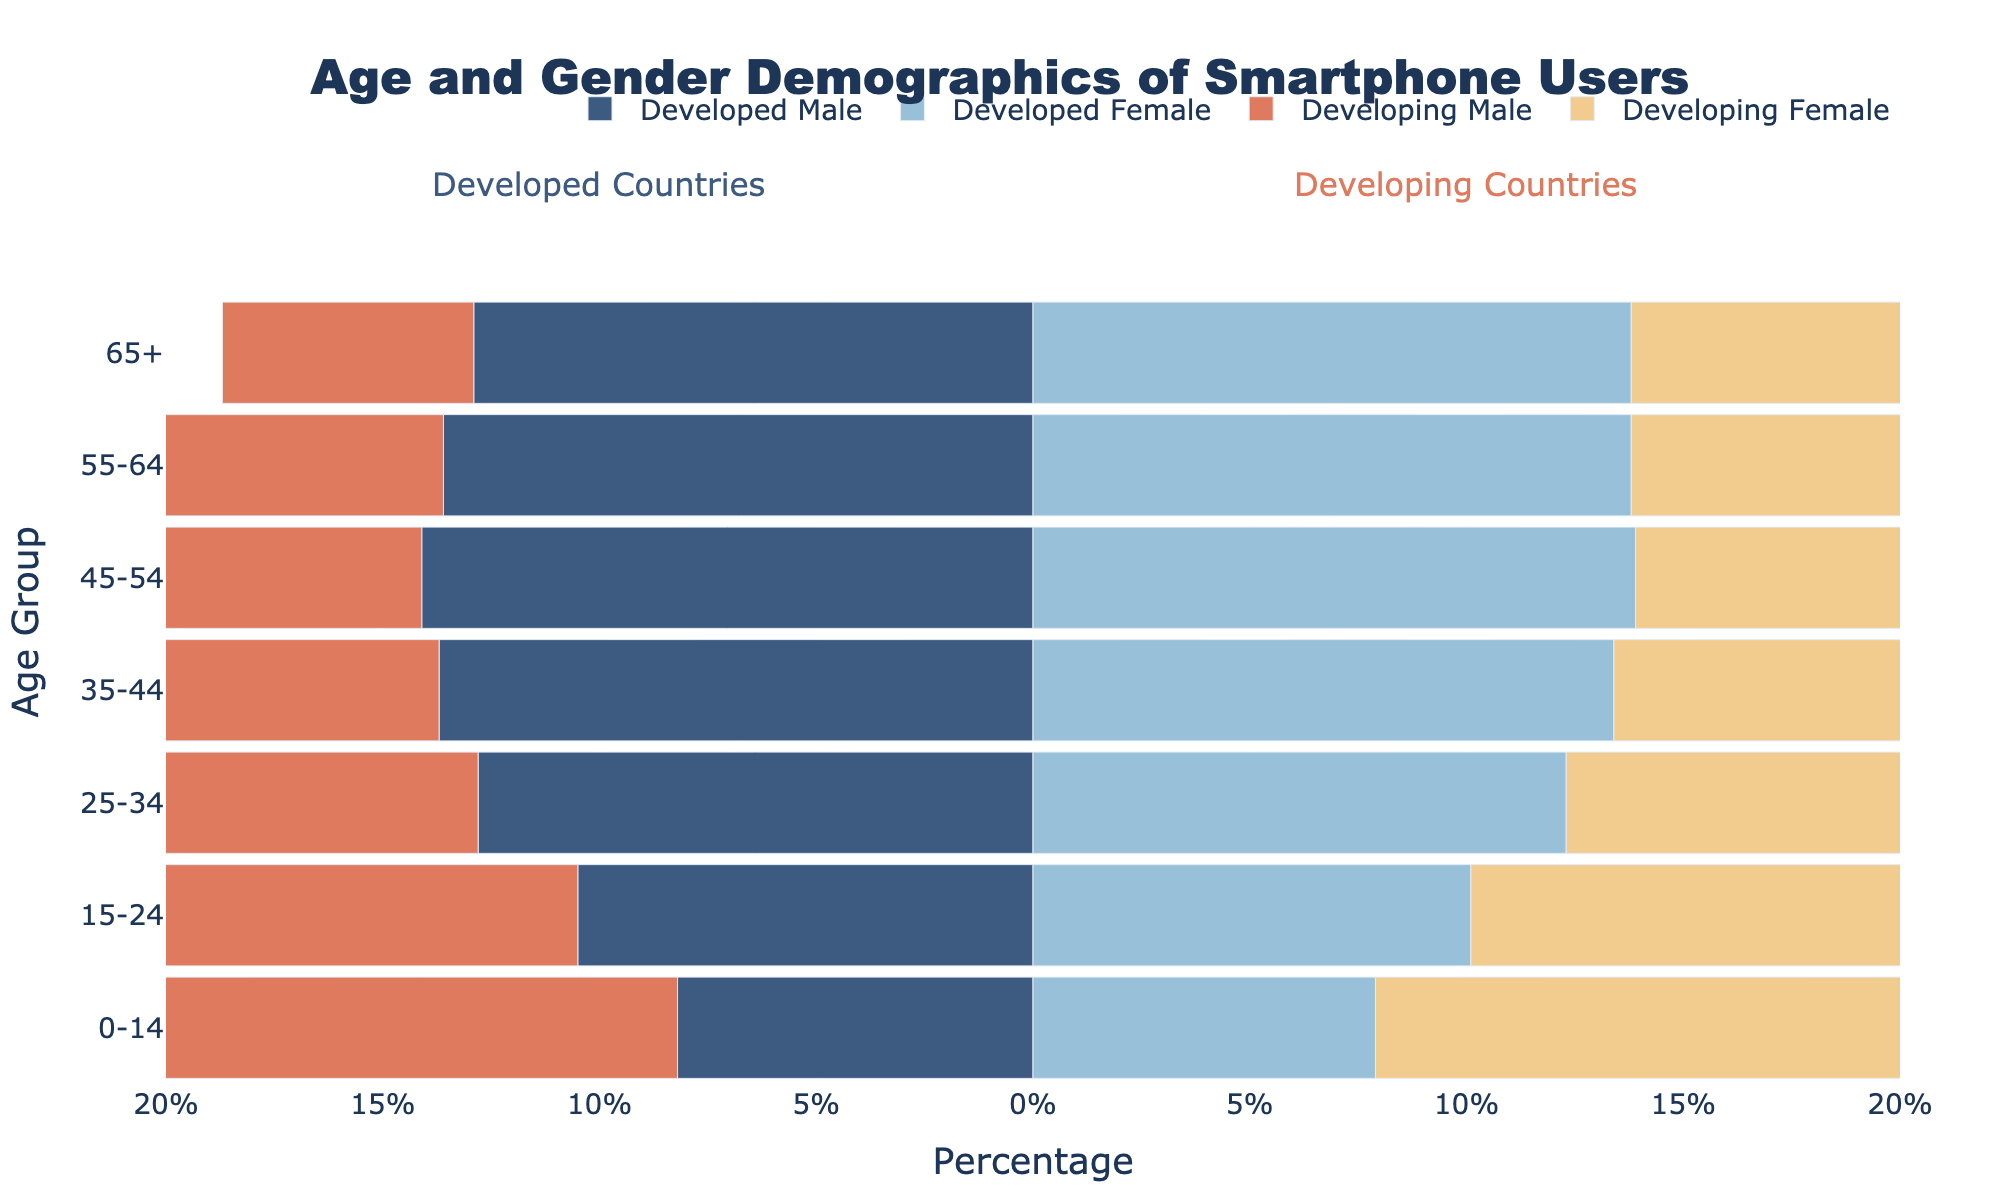Which age group has the highest percentage of smartphone users in developed countries? By looking at the bars representing developed countries, the age group 45-54 has the highest percentages for both males (14.1%) and females (13.9%).
Answer: 45-54 How do the percentages of male smartphone users aged 0-14 between developed and developing countries compare? For developed countries, it's 8.2%, and for developing countries, it's 15.6%. Clearly, developing countries have almost double the percentage.
Answer: Developing > Developed What is the total percentage of female smartphone users aged 25-34 in both developed and developing countries combined? Add the percentages for females aged 25-34 in developed (12.3%) and developing (16.4%) countries. 12.3% + 16.4% = 28.7%.
Answer: 28.7% Among the age group 55-64, in which set of countries do you see a higher percentage of female smartphone users? Developed countries have 13.8%, while developing countries have 8.7%. Clearly, developed countries have a higher percentage.
Answer: Developed Which gender in developing countries has the smallest percentage of smartphone users aged 65+? The developing male bar for the 65+ age group is at 5.8%, which is smaller than the developing female bar at 6.9%.
Answer: Male How does the percentage of smartphone users aged 35-44 compare between developed and developing countries for both genders? For males, developed is 13.7% and developing is 14.2%. For females, developed is 13.4% and developing is 13.9%. In both cases, developing has slightly higher percentages.
Answer: Developing > Developed What is the difference between the percentage of developed female and developing male smartphone users aged 65+? The percentage for developed female is 13.8% and for developing male is 5.8%. The difference is 13.8% - 5.8% = 8.0%.
Answer: 8.0% What age group in developed countries shows the most balanced percentage of smartphone use between males and females? The age group 0-14 shows a slight difference, with males at 8.2% and females at 7.9%. This is the most balanced compared to other age groups.
Answer: 0-14 Which age group in developing countries has the highest combined percentage of male and female smartphone users? Sum the percentages for each age group and identify the highest. Age group 15-24: males (18.2%) + females (17.5%) = 35.7%, which is the highest.
Answer: 15-24 